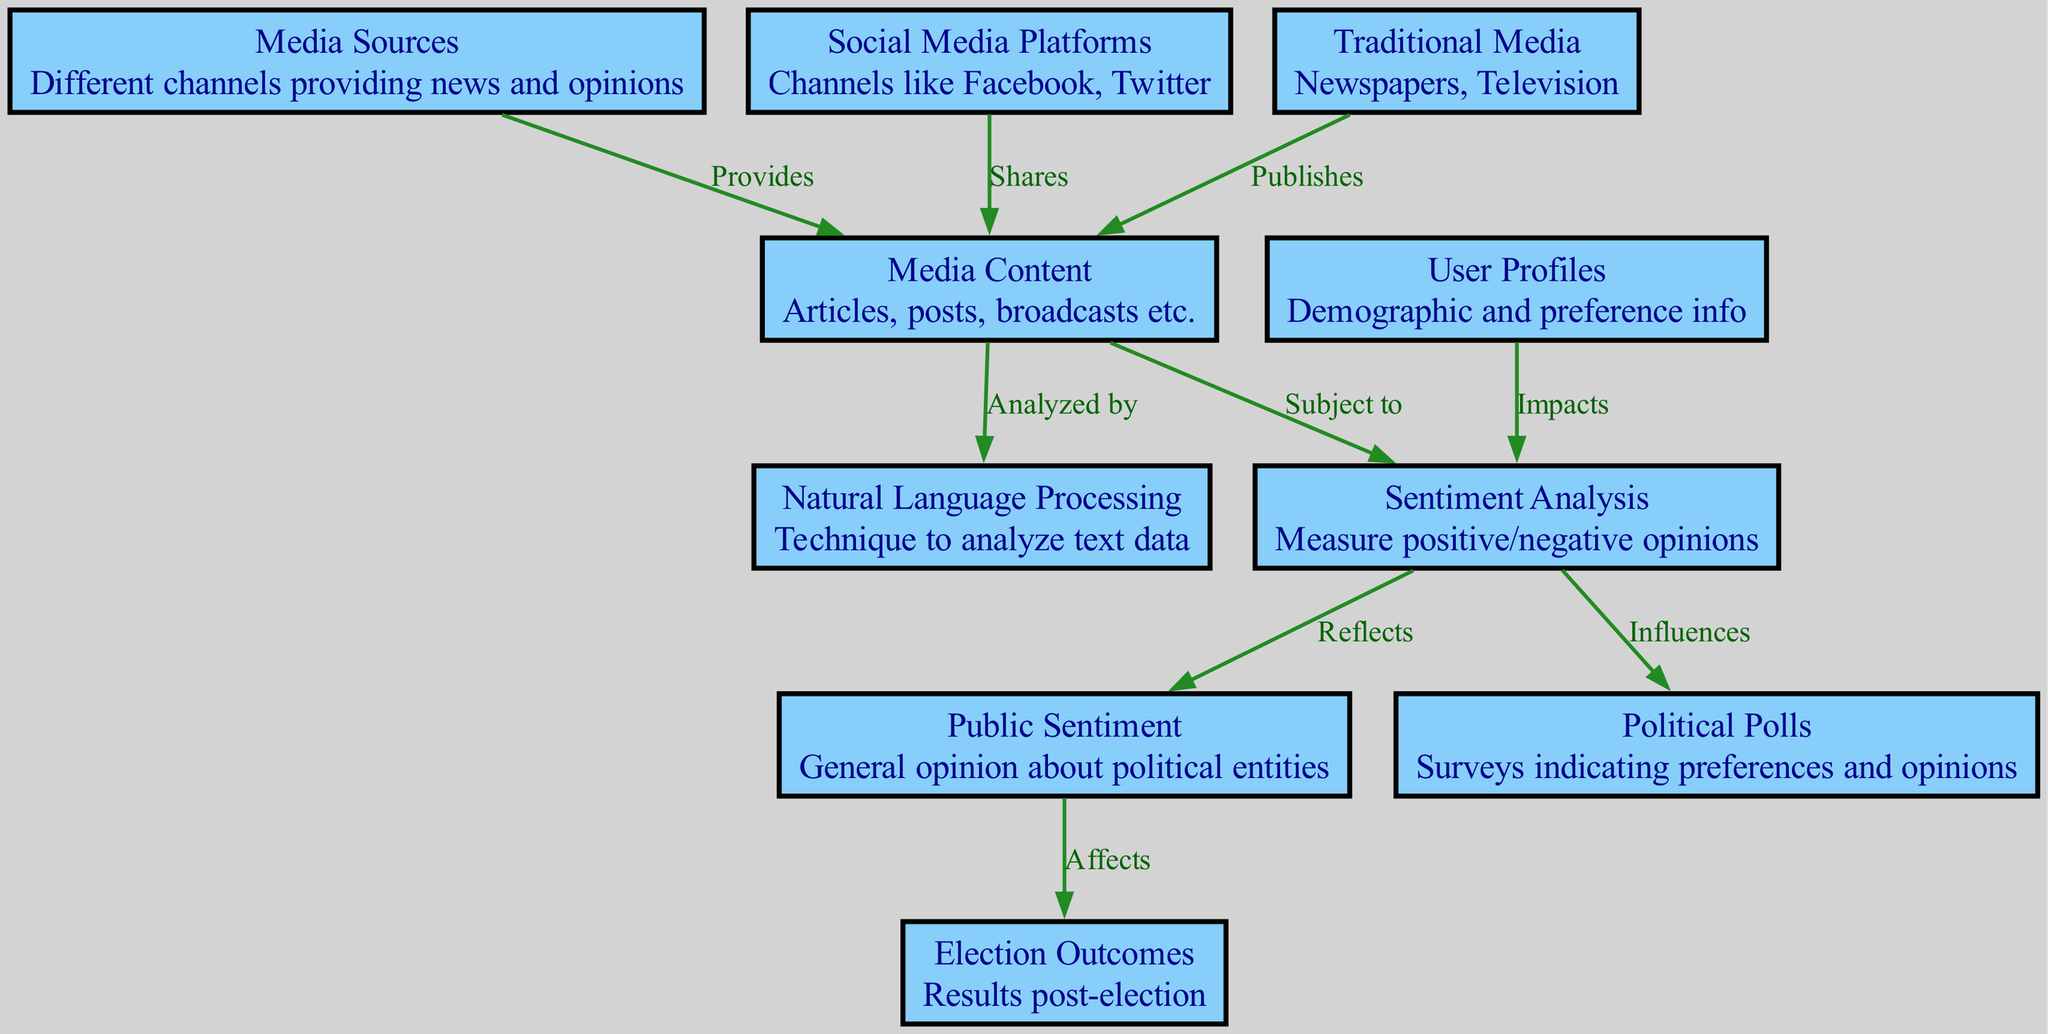What are the two types of media sources represented in the diagram? The diagram identifies "Social Media Platforms" and "Traditional Media" as the two types of media sources. These nodes are distinct and provide different avenues for news dissemination.
Answer: Social Media Platforms, Traditional Media How many nodes are present in this diagram? The diagram contains a total of 10 nodes, each representing different aspects of the media influence on public opinion and election cycles.
Answer: 10 Which node is influenced by sentiment analysis? The "Public Sentiment" node is influenced by sentiment analysis, as indicated by the edge connecting them, showing that sentiment analysis measures opinions which reflect in public sentiment.
Answer: Public Sentiment What reflects public sentiment in this diagram? The "Sentiment Analysis" node reflects public sentiment, as it is linked to the "Public Sentiment" node, demonstrating the flow of analysis leading to public opinions.
Answer: Sentiment Analysis How many edges are there in the diagram? There are a total of 8 edges in the diagram, which indicate various relationships between the nodes regarding the influence of media on public opinion and election outcomes.
Answer: 8 Which node affects election outcomes? "Public Sentiment" affects "Election Outcomes" as depicted by the directed edge flowing from the public sentiment to the election results, indicating the impact of public opinion on the outcomes.
Answer: Election Outcomes What is analyzed by natural language processing? The "Media Content" is analyzed by "Natural Language Processing," showing that the content from various media sources is processed to extract usable insights.
Answer: Media Content Which node impacts sentiment analysis based on user information? The "User Profiles" node impacts "Sentiment Analysis" according to the diagram, suggesting that demographic and preference information helps in interpreting sentiments.
Answer: User Profiles 